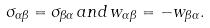<formula> <loc_0><loc_0><loc_500><loc_500>\sigma _ { \alpha \beta } = \sigma _ { \beta \alpha } \, a n d \, w _ { \alpha \beta } = - w _ { \beta \alpha } .</formula> 